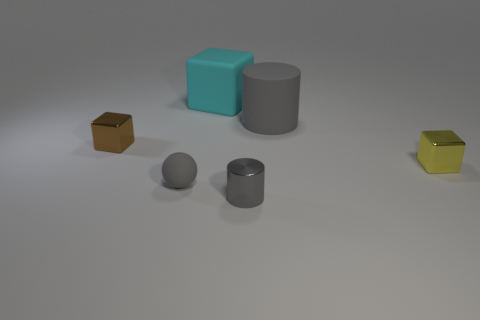Subtract all blue cylinders. Subtract all gray blocks. How many cylinders are left? 2 Add 3 shiny cubes. How many objects exist? 9 Subtract all cylinders. How many objects are left? 4 Add 5 large rubber cylinders. How many large rubber cylinders are left? 6 Add 6 big red blocks. How many big red blocks exist? 6 Subtract 0 yellow cylinders. How many objects are left? 6 Subtract all cylinders. Subtract all small brown metallic cubes. How many objects are left? 3 